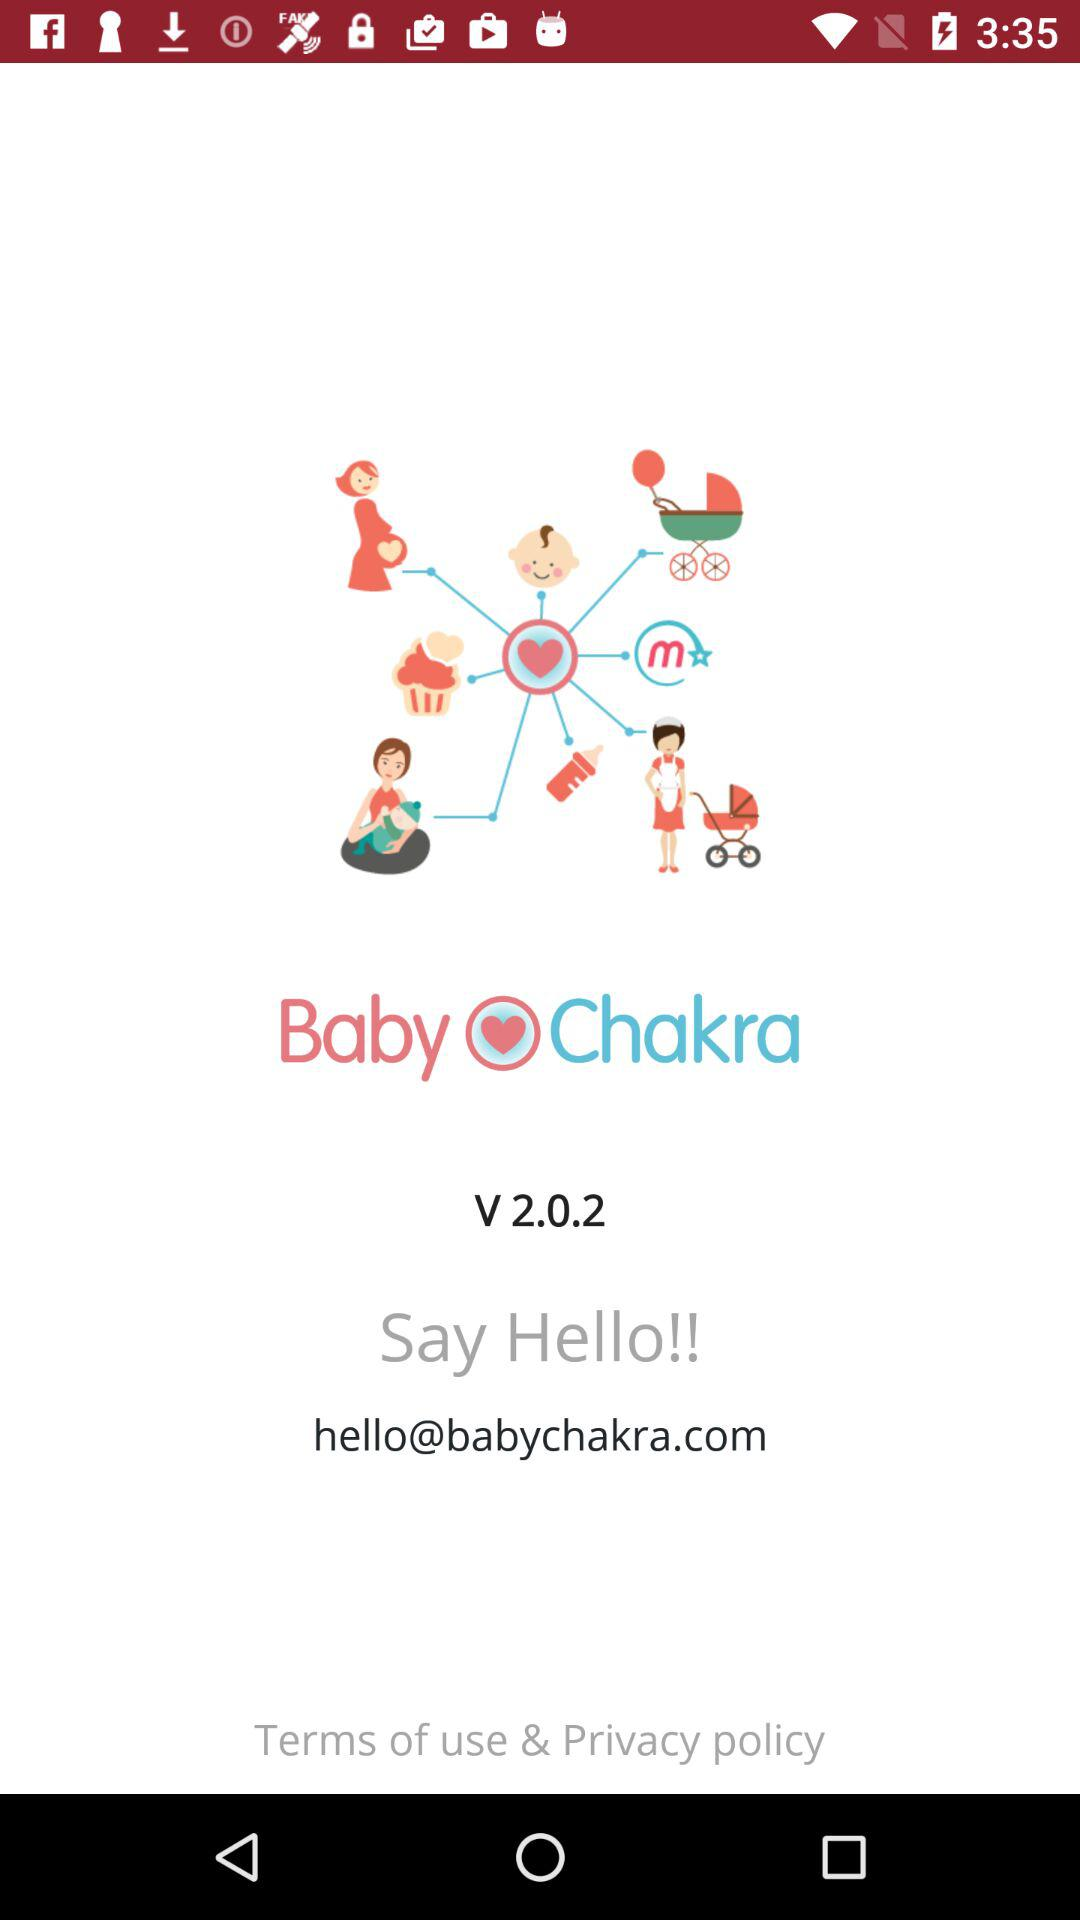What is the name of the application? The name of the application is "Baby Chakra". 